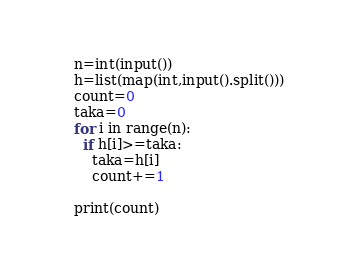Convert code to text. <code><loc_0><loc_0><loc_500><loc_500><_Python_>n=int(input())
h=list(map(int,input().split()))
count=0
taka=0
for i in range(n):
  if h[i]>=taka:
    taka=h[i]
    count+=1
    
print(count)</code> 